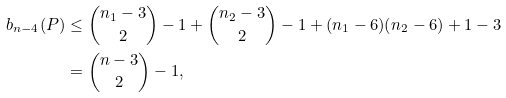Convert formula to latex. <formula><loc_0><loc_0><loc_500><loc_500>b _ { n - 4 } ( P ) & \leq \binom { n _ { 1 } - 3 } 2 - 1 + \binom { n _ { 2 } - 3 } 2 - 1 + ( n _ { 1 } - 6 ) ( n _ { 2 } - 6 ) + 1 - 3 \\ & = \binom { n - 3 } 2 - 1 ,</formula> 